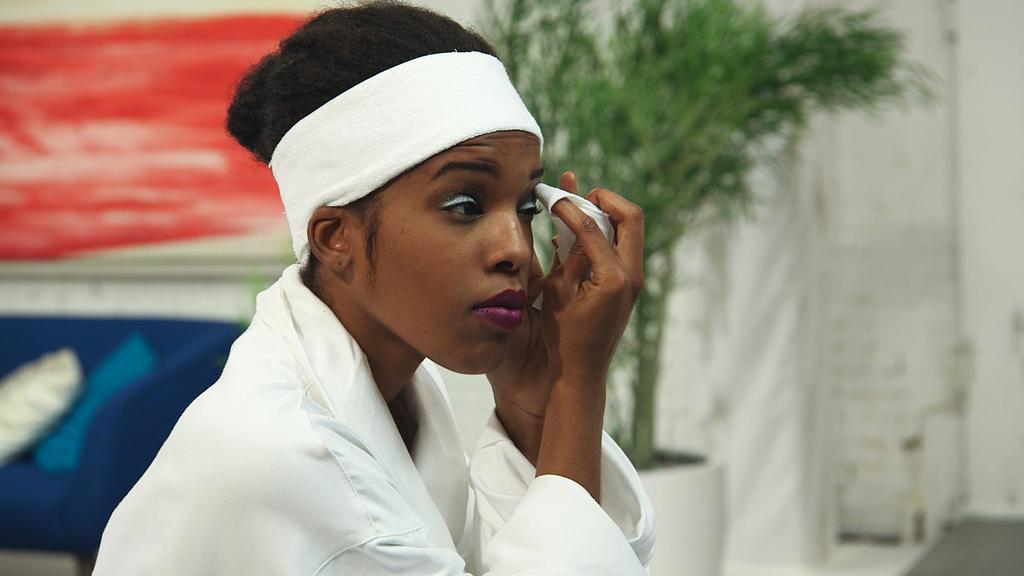In one or two sentences, can you explain what this image depicts? In the picture we can see a woman sitting and doing her makeup to her eyes holding a white colored cloth and she is in a white dress and white color band to her head and beside her we can see a part of the sofa which is blue in color with two pillows on it and besides we can see a house plant. 